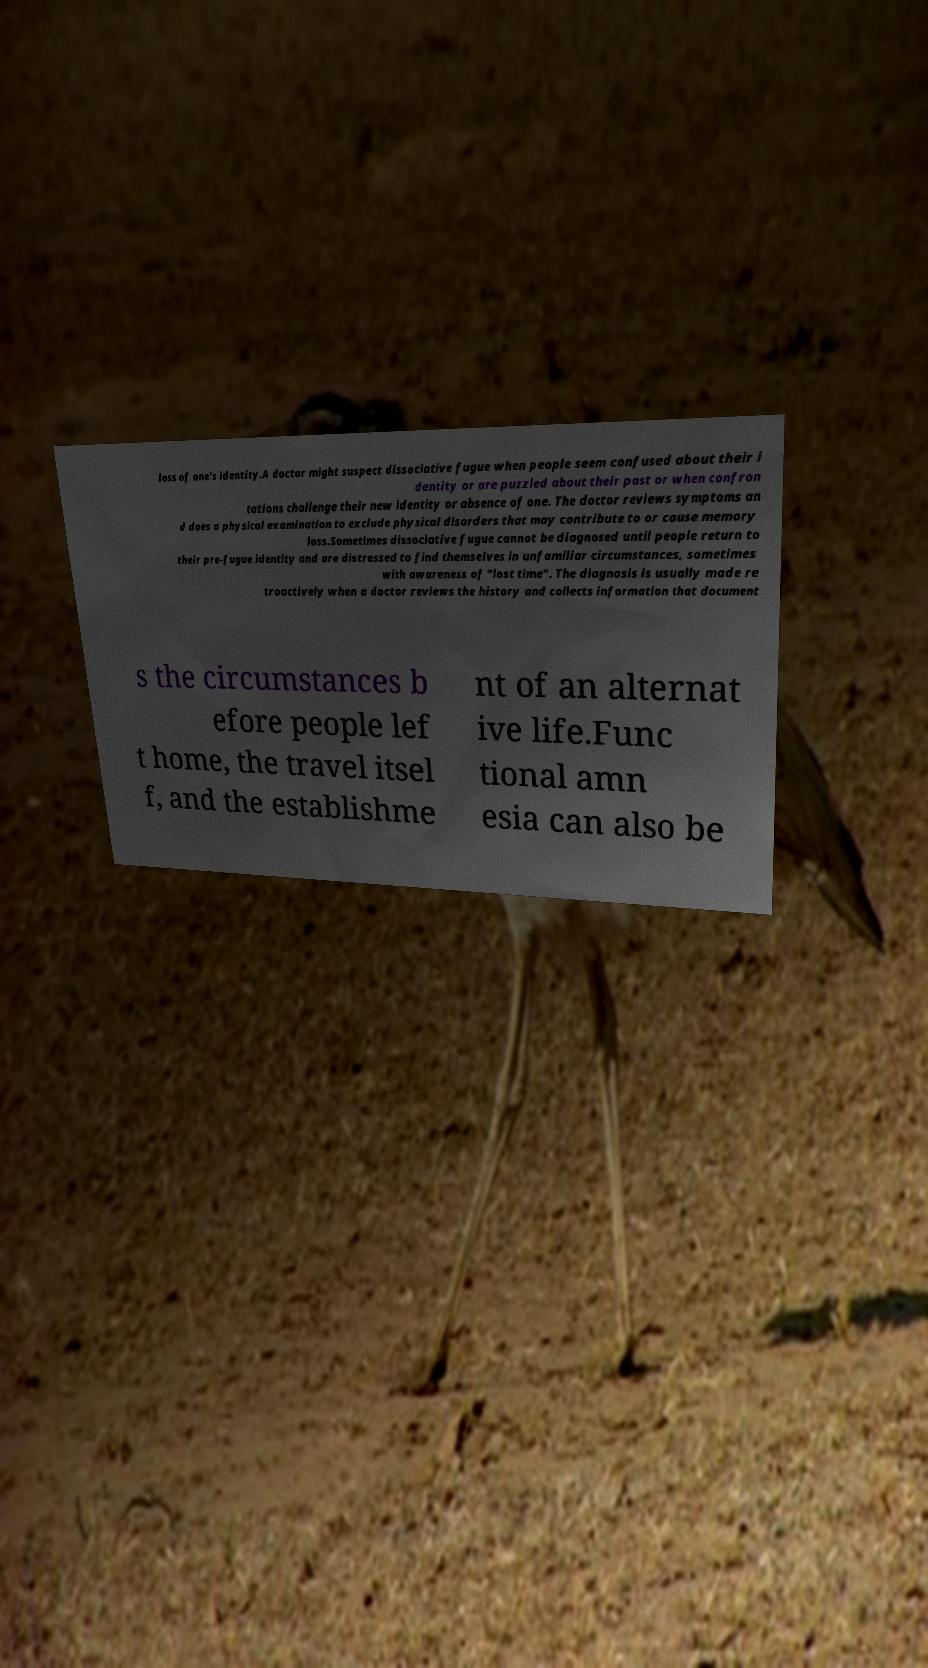There's text embedded in this image that I need extracted. Can you transcribe it verbatim? loss of one's identity.A doctor might suspect dissociative fugue when people seem confused about their i dentity or are puzzled about their past or when confron tations challenge their new identity or absence of one. The doctor reviews symptoms an d does a physical examination to exclude physical disorders that may contribute to or cause memory loss.Sometimes dissociative fugue cannot be diagnosed until people return to their pre-fugue identity and are distressed to find themselves in unfamiliar circumstances, sometimes with awareness of "lost time". The diagnosis is usually made re troactively when a doctor reviews the history and collects information that document s the circumstances b efore people lef t home, the travel itsel f, and the establishme nt of an alternat ive life.Func tional amn esia can also be 